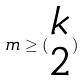<formula> <loc_0><loc_0><loc_500><loc_500>m \geq ( \begin{matrix} k \\ 2 \end{matrix} )</formula> 